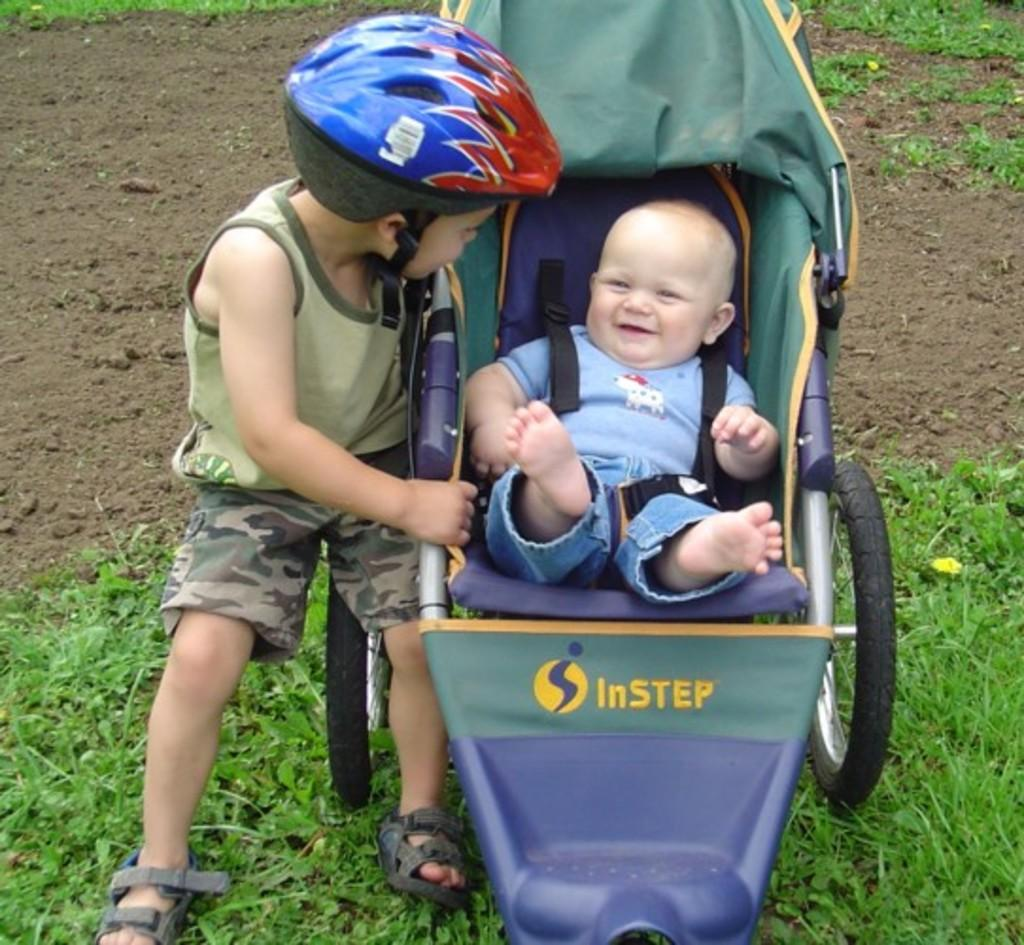What is the kid in the image wearing on their head? The kid is wearing a helmet in the image. What type of mobility aid is the kid using? The kid is sitting on a wheelchair. Can you describe the other kid in the image? The other kid is wearing a blue dress and is also sitting in a wheelchair. What can be seen in the background of the image? The background of the image includes grass. What type of truck can be seen in the background of the image? There is no truck visible in the background of the image; it only includes grass. How many bears are present in the image? There are no bears present in the image. 